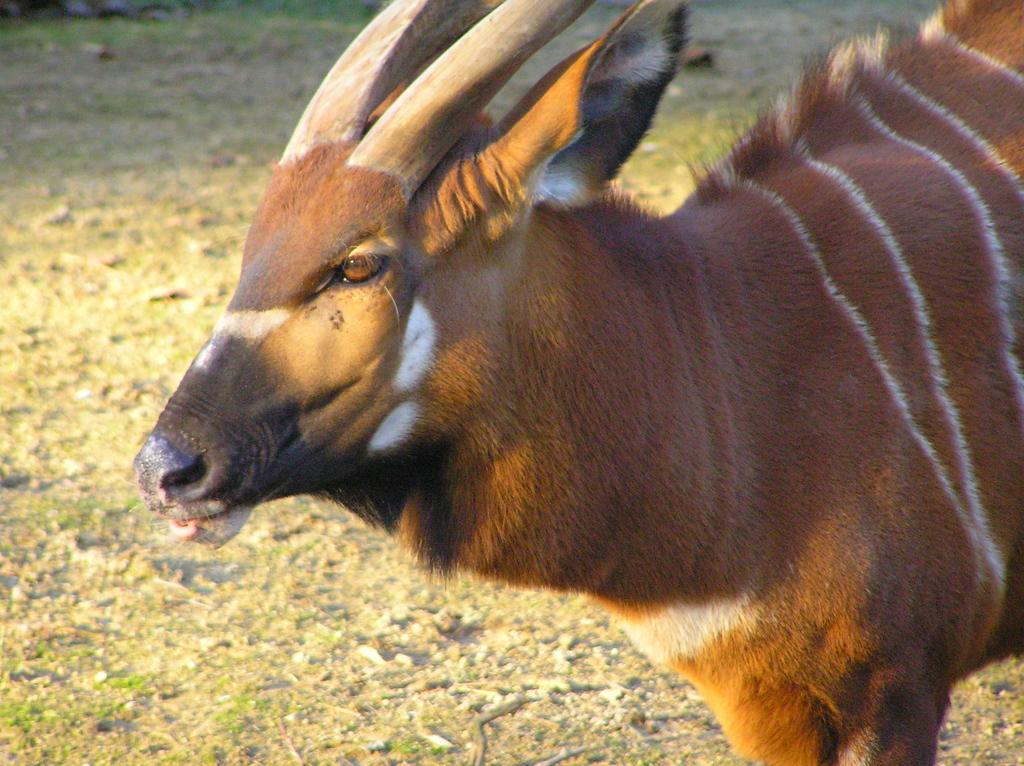What animal is the main subject of the image? There is a bull in the image. What is the bull's position in the image? The bull is standing on the ground. What type of screw can be seen holding the bull's horns together in the image? There is no screw present in the image, and the bull's horns are not held together by any visible object. 